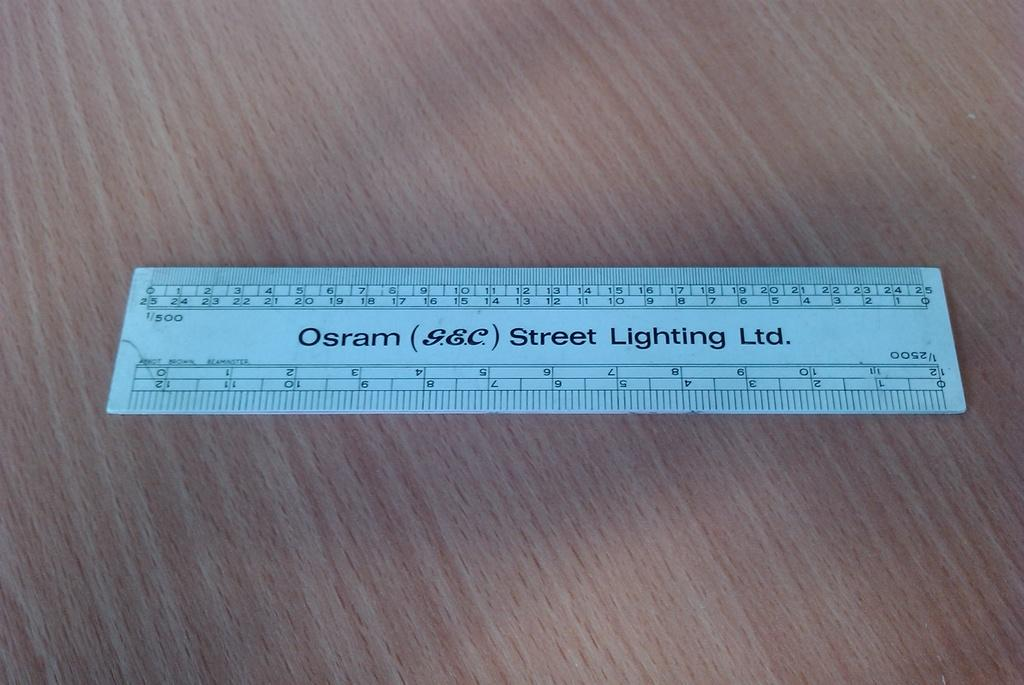What is the main object in the image? There is a scale in the image. What is the scale placed on? The scale is on a wooden object. Are there any words or letters on the scale? Yes, there is text on the scale. What type of information can be found on the scale? There are numbers on the scale. Can you see a patch of grapes on the wooden object in the image? There is no patch of grapes visible in the image; the focus is on the scale and its features. 